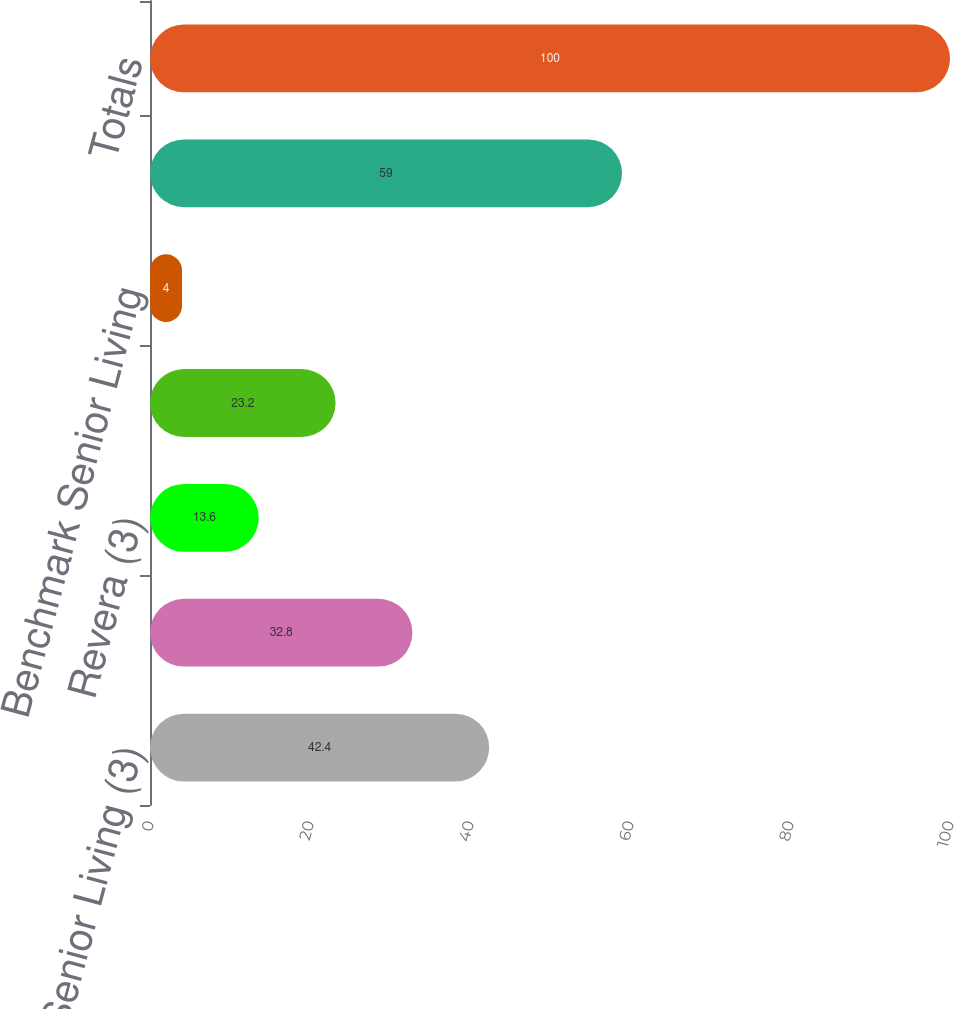<chart> <loc_0><loc_0><loc_500><loc_500><bar_chart><fcel>Sunrise Senior Living (3)<fcel>Genesis HealthCare<fcel>Revera (3)<fcel>Brookdale Senior Living<fcel>Benchmark Senior Living<fcel>Remaining portfolio<fcel>Totals<nl><fcel>42.4<fcel>32.8<fcel>13.6<fcel>23.2<fcel>4<fcel>59<fcel>100<nl></chart> 